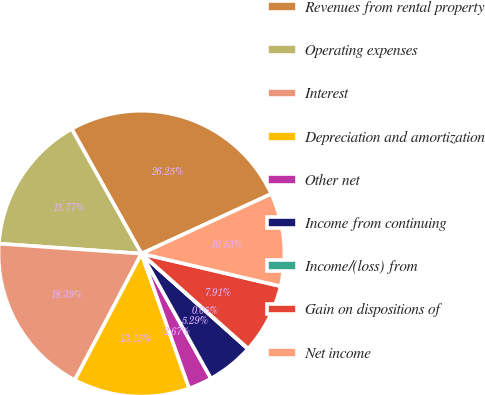Convert chart to OTSL. <chart><loc_0><loc_0><loc_500><loc_500><pie_chart><fcel>Revenues from rental property<fcel>Operating expenses<fcel>Interest<fcel>Depreciation and amortization<fcel>Other net<fcel>Income from continuing<fcel>Income/(loss) from<fcel>Gain on dispositions of<fcel>Net income<nl><fcel>26.25%<fcel>15.77%<fcel>18.39%<fcel>13.15%<fcel>2.67%<fcel>5.29%<fcel>0.05%<fcel>7.91%<fcel>10.53%<nl></chart> 